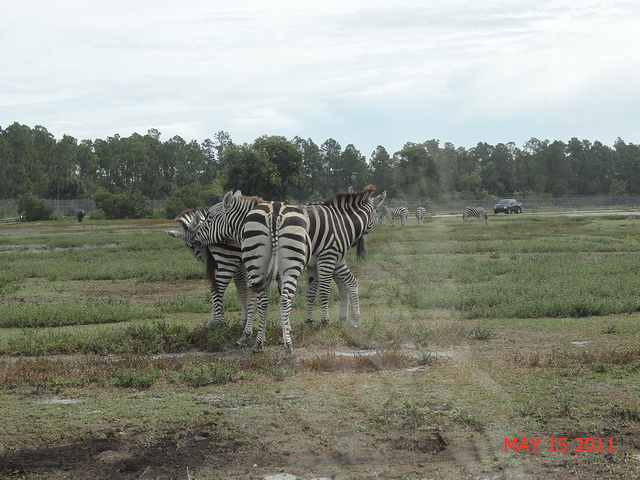What are the zebras doing in the photo? The zebras appear to be grazing and standing calmly together. Their close proximity to one another could suggest social bonding, as zebras are known for their strong herd behaviors. Are zebras typically found in this type of environment? Zebras are commonly found in a variety of grassland habitats in Africa. This particular setting, with flat and sparse vegetation, is reminiscent of their natural habitats, although the presence of a vehicle in the background suggests it might be a protected area such as a wildlife reserve or sanctuary. 